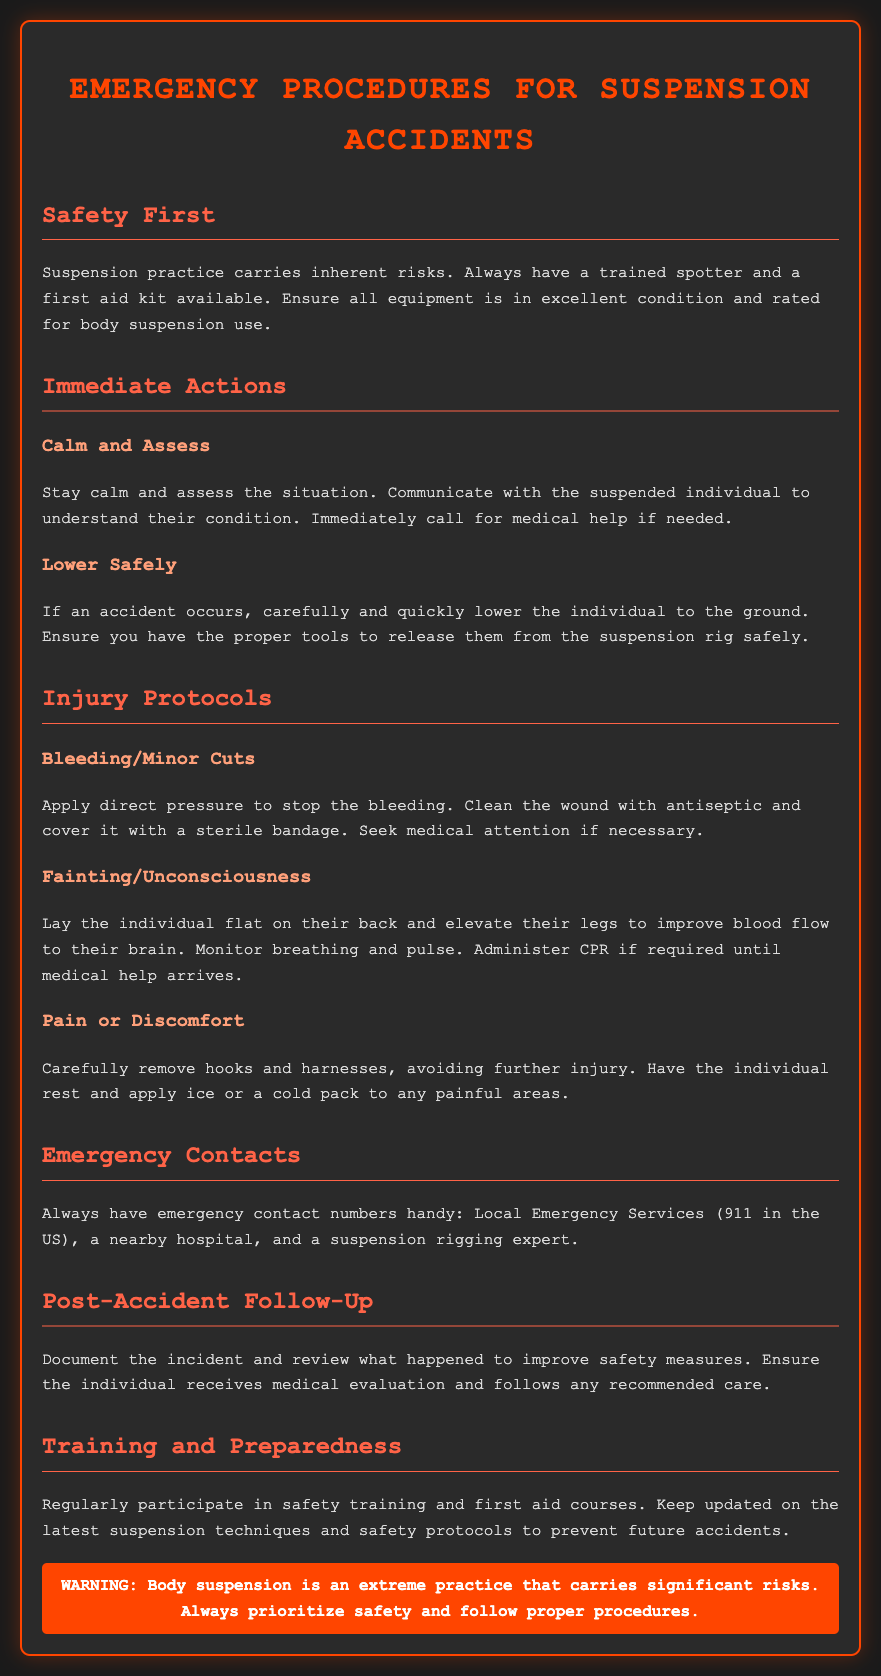What is the primary focus of this document? The primary focus of the document is on emergency procedures for body suspension accidents, outlining safety measures and protocols.
Answer: Emergency procedures for suspension accidents How should you communicate with a suspended individual in case of an accident? Communication is emphasized to understand the condition of the suspended individual during an emergency.
Answer: Understand their condition What is the number to call for local emergency services in the US? The document specifically states the number for local emergency services in the US.
Answer: 911 What should you do for bleeding or minor cuts? The document outlines the procedure for treating bleeding or minor cuts, which includes applying direct pressure and cleaning the wound.
Answer: Apply direct pressure What immediate action should be taken after assessing the situation? The document indicates that calling for medical help is crucial after assessing the situation.
Answer: Call for medical help What type of training is recommended for safety preparedness? The document recommends regular participation in safety training and first aid courses to improve preparedness.
Answer: Safety training and first aid courses What should be documented after an accident? The document states that it is important to document the incident to improve safety measures.
Answer: The incident What comes after the immediate action of lowering the suspended person? After lowering, the document suggests safely releasing them from the suspension rig.
Answer: Safely release them What should be done if an individual is fainting or unconscious? For fainting or unconsciousness, the procedure involves laying them flat and elevating their legs to improve blood flow.
Answer: Lay flat and elevate legs 